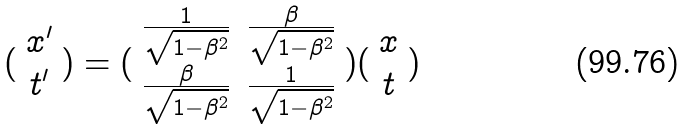Convert formula to latex. <formula><loc_0><loc_0><loc_500><loc_500>( \begin{array} { c } x ^ { \prime } \\ t ^ { \prime } \end{array} ) = ( \begin{array} { c c } \frac { 1 } { \sqrt { 1 - \beta ^ { 2 } } } & \frac { \beta } { \sqrt { 1 - \beta ^ { 2 } } } \\ \frac { \beta } { \sqrt { 1 - \beta ^ { 2 } } } & \frac { 1 } { \sqrt { 1 - \beta ^ { 2 } } } \end{array} ) ( \begin{array} { c } x \\ t \end{array} )</formula> 